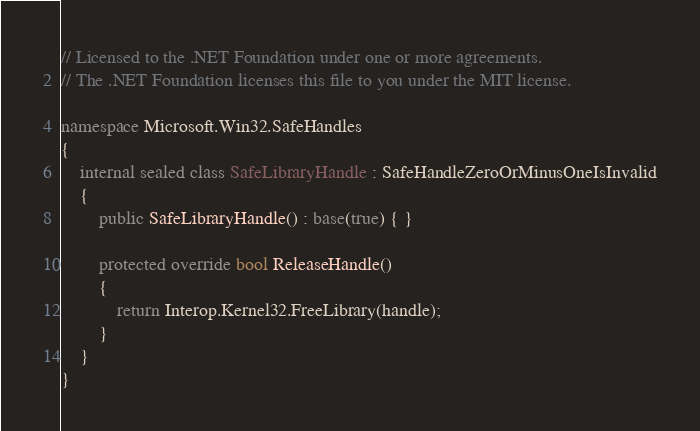Convert code to text. <code><loc_0><loc_0><loc_500><loc_500><_C#_>// Licensed to the .NET Foundation under one or more agreements.
// The .NET Foundation licenses this file to you under the MIT license.

namespace Microsoft.Win32.SafeHandles
{
    internal sealed class SafeLibraryHandle : SafeHandleZeroOrMinusOneIsInvalid
    {
        public SafeLibraryHandle() : base(true) { }

        protected override bool ReleaseHandle()
        {
            return Interop.Kernel32.FreeLibrary(handle);
        }
    }
}
</code> 